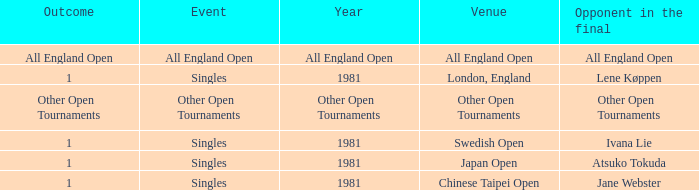Parse the full table. {'header': ['Outcome', 'Event', 'Year', 'Venue', 'Opponent in the final'], 'rows': [['All England Open', 'All England Open', 'All England Open', 'All England Open', 'All England Open'], ['1', 'Singles', '1981', 'London, England', 'Lene Køppen'], ['Other Open Tournaments', 'Other Open Tournaments', 'Other Open Tournaments', 'Other Open Tournaments', 'Other Open Tournaments'], ['1', 'Singles', '1981', 'Swedish Open', 'Ivana Lie'], ['1', 'Singles', '1981', 'Japan Open', 'Atsuko Tokuda'], ['1', 'Singles', '1981', 'Chinese Taipei Open', 'Jane Webster']]} What is the competitor in the ultimate match with an all england open resolution? All England Open. 